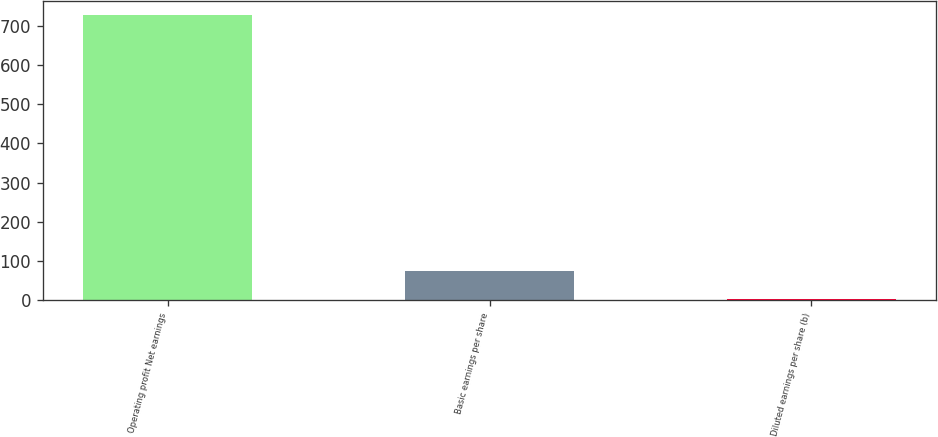<chart> <loc_0><loc_0><loc_500><loc_500><bar_chart><fcel>Operating profit Net earnings<fcel>Basic earnings per share<fcel>Diluted earnings per share (b)<nl><fcel>727<fcel>74.69<fcel>2.21<nl></chart> 